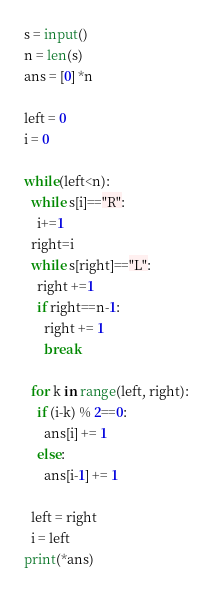Convert code to text. <code><loc_0><loc_0><loc_500><loc_500><_Python_>s = input()
n = len(s)
ans = [0] *n 

left = 0
i = 0

while(left<n):
  while s[i]=="R":
    i+=1
  right=i
  while s[right]=="L":
    right +=1
    if right==n-1:
      right += 1
      break

  for k in range(left, right):
    if (i-k) % 2==0:
      ans[i] += 1
    else:
      ans[i-1] += 1

  left = right
  i = left
print(*ans)


</code> 